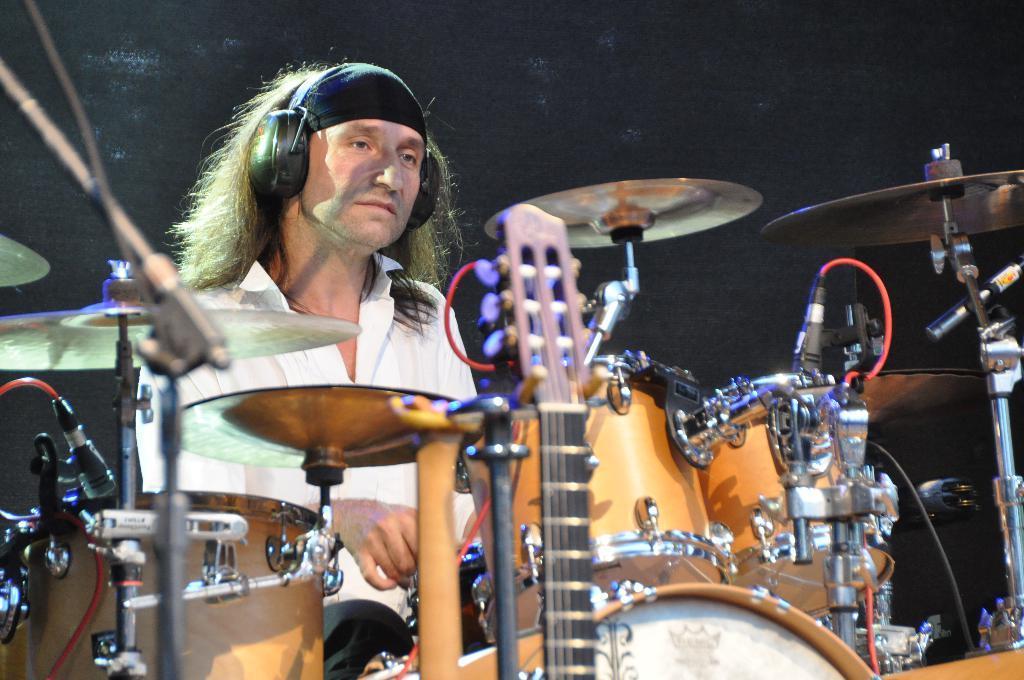Describe this image in one or two sentences. In this image I can see a person sitting and playing drums. The person is wearing white shirt, I can also see few musical instruments and the background is in black color. 